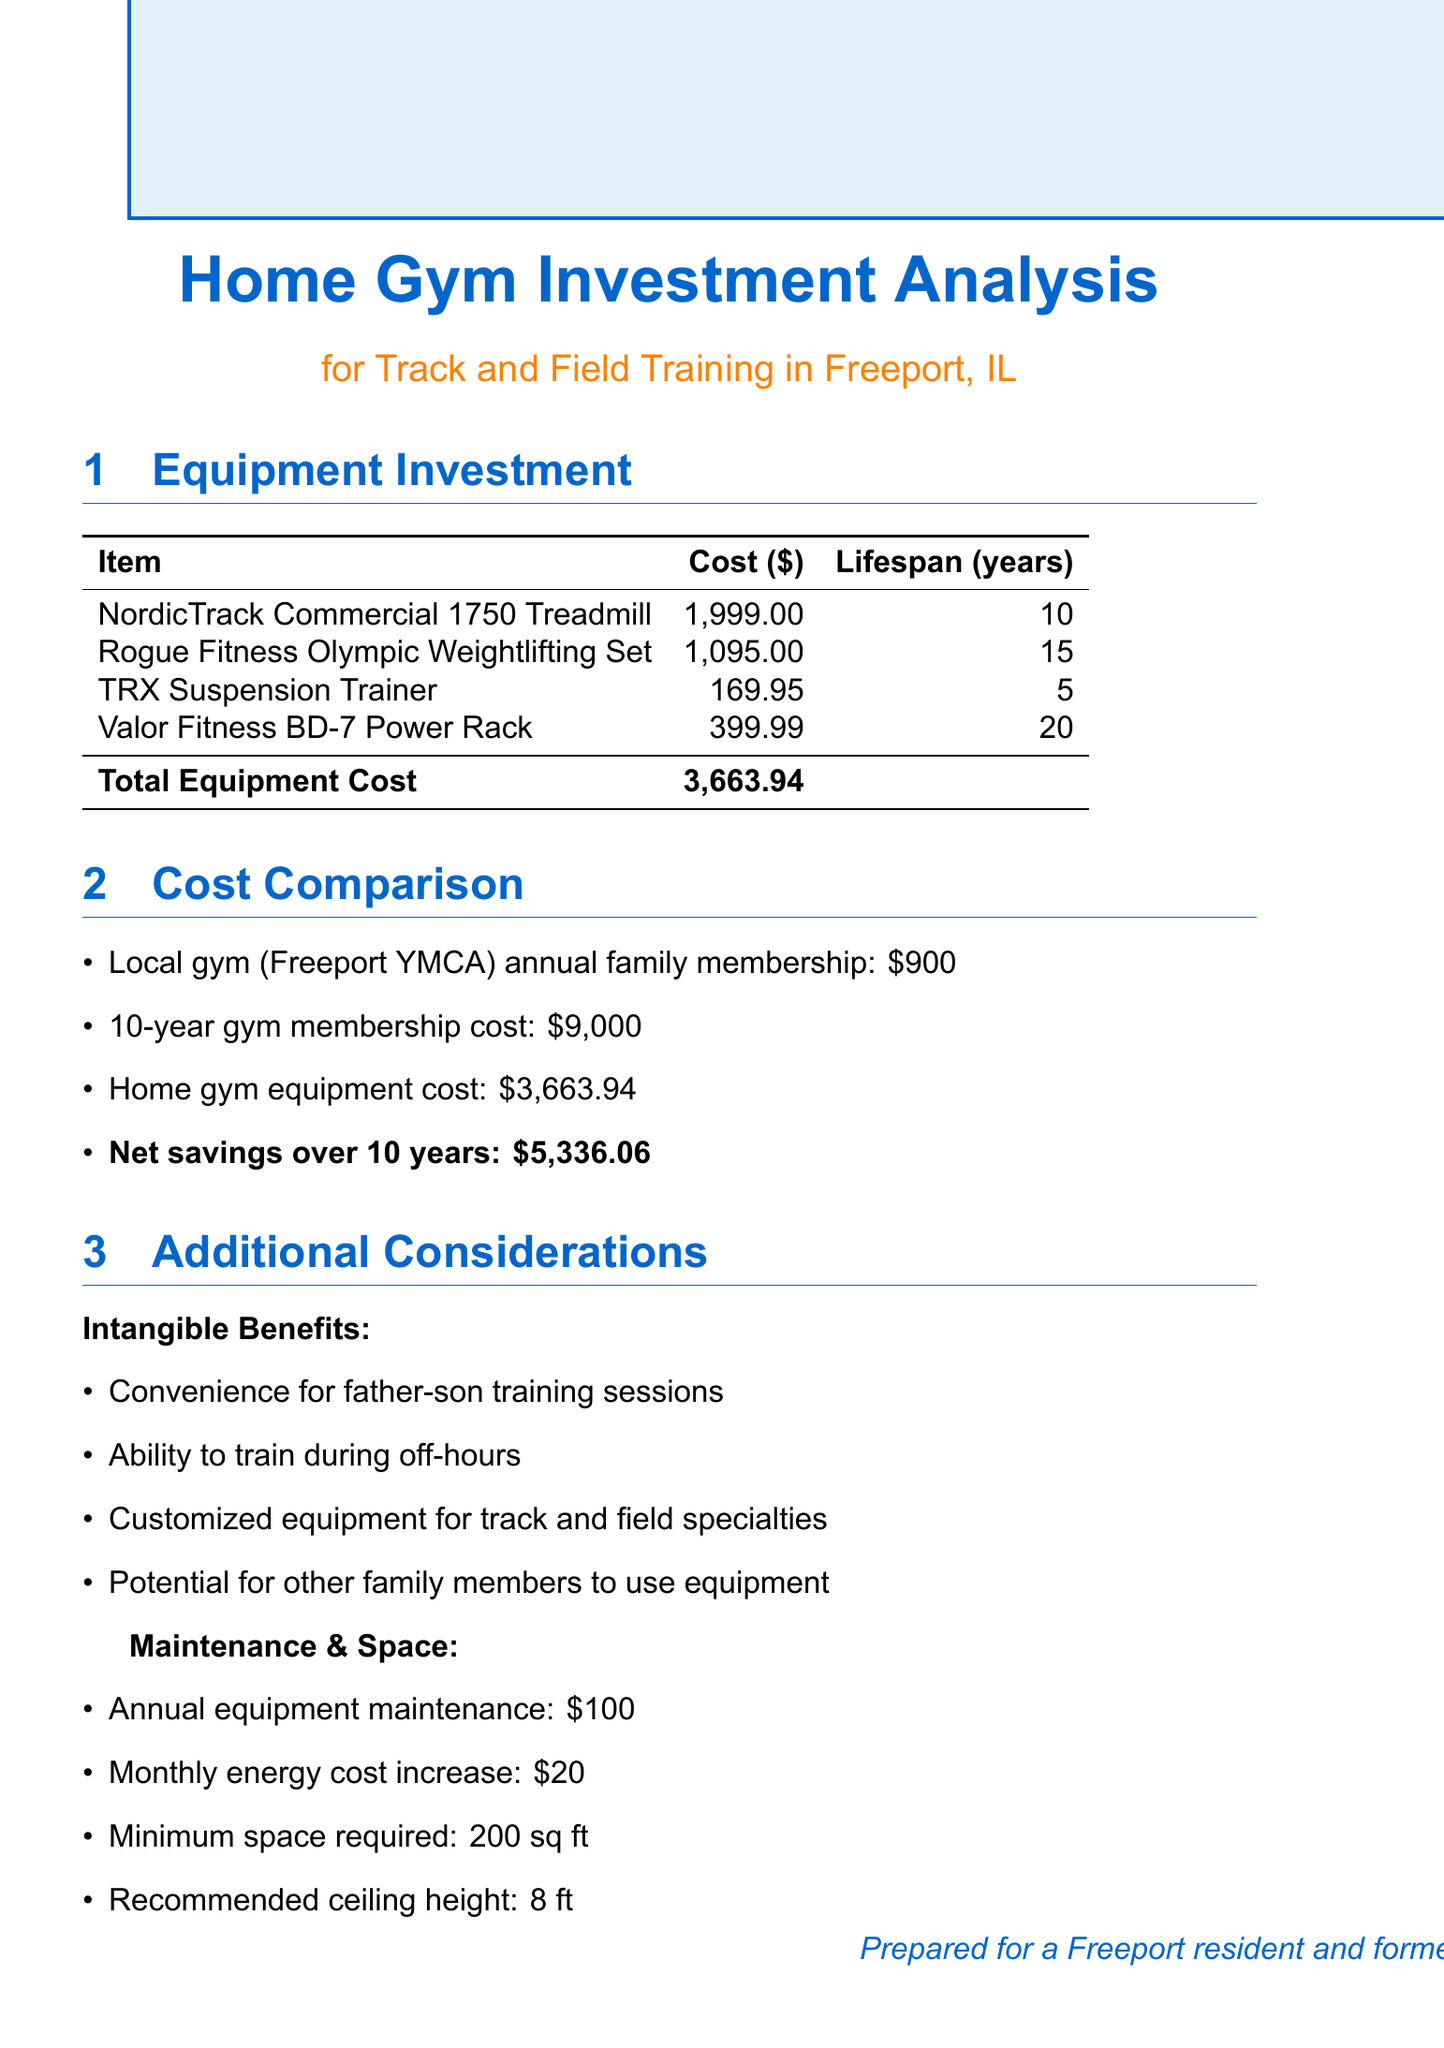what is the total equipment cost? The total equipment cost is listed in the document and is the sum of all individual equipment costs.
Answer: 3,663.94 what is the annual family membership cost at the local gym? The document provides the cost of the annual family membership for the Freeport YMCA.
Answer: 900 how much can be potentially saved over 10 years? The net savings is calculated by subtracting the total equipment cost from the gym membership cost over 10 years.
Answer: 5,336.06 what is the lifespan of the TRX Suspension Trainer? The lifespan of the TRX Suspension Trainer is specifically mentioned in the equipment investment section of the document.
Answer: 5 what are the intangible benefits listed in the report? The document enumerates reasons for the added value of having a home gym, which are not directly financial.
Answer: Convenience for father-son training sessions, Ability to train during off-hours, Customized equipment for track and field specialties, Potential for other family members to use equipment what is the minimum space required for the home gym? The document states the minimum space requirement necessary for setting up the home gym.
Answer: 200 sq ft how long is the lifespan of the Rogue Fitness Olympic Weightlifting Set? The lifespan is provided in the equipment details section of the document.
Answer: 15 what is the monthly increase in energy costs? The document details the additional monthly cost for energy related to maintaining the gym equipment.
Answer: 20 